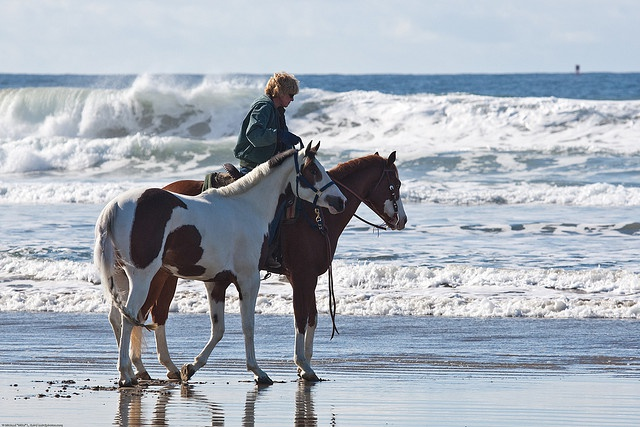Describe the objects in this image and their specific colors. I can see horse in lightgray, gray, and black tones, horse in lightgray, black, gray, and maroon tones, and people in lightgray, black, gray, and darkblue tones in this image. 